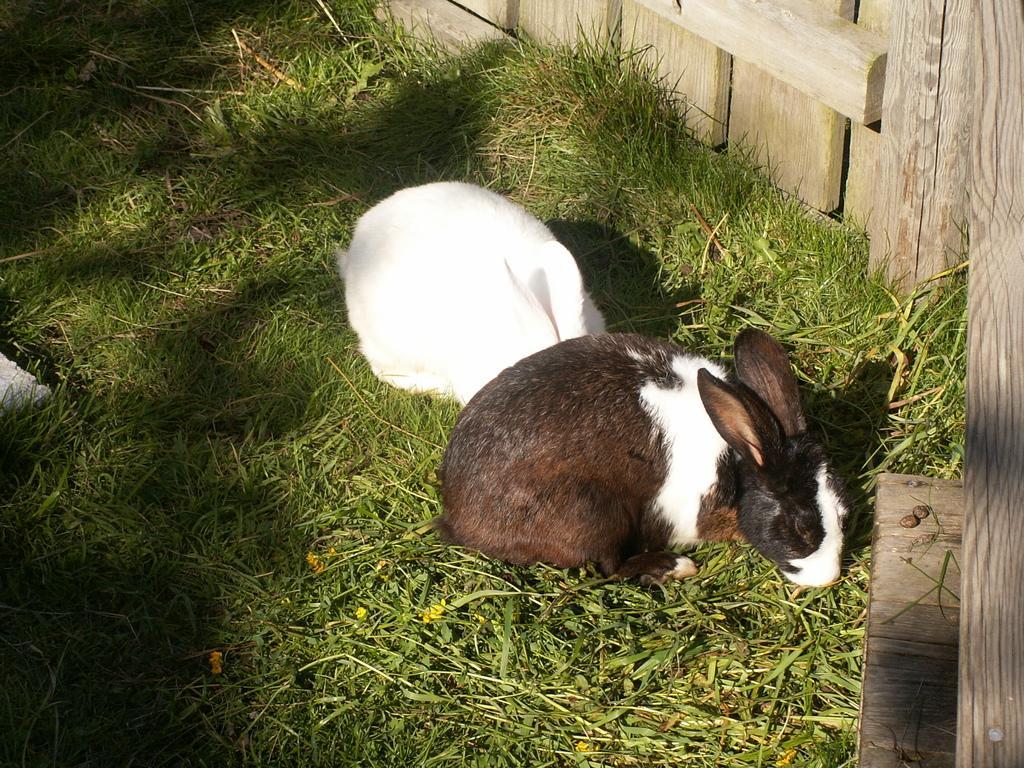Can you describe this image briefly? In this image there are two rabbits on the surface of the grass and there is a wooden fence. 